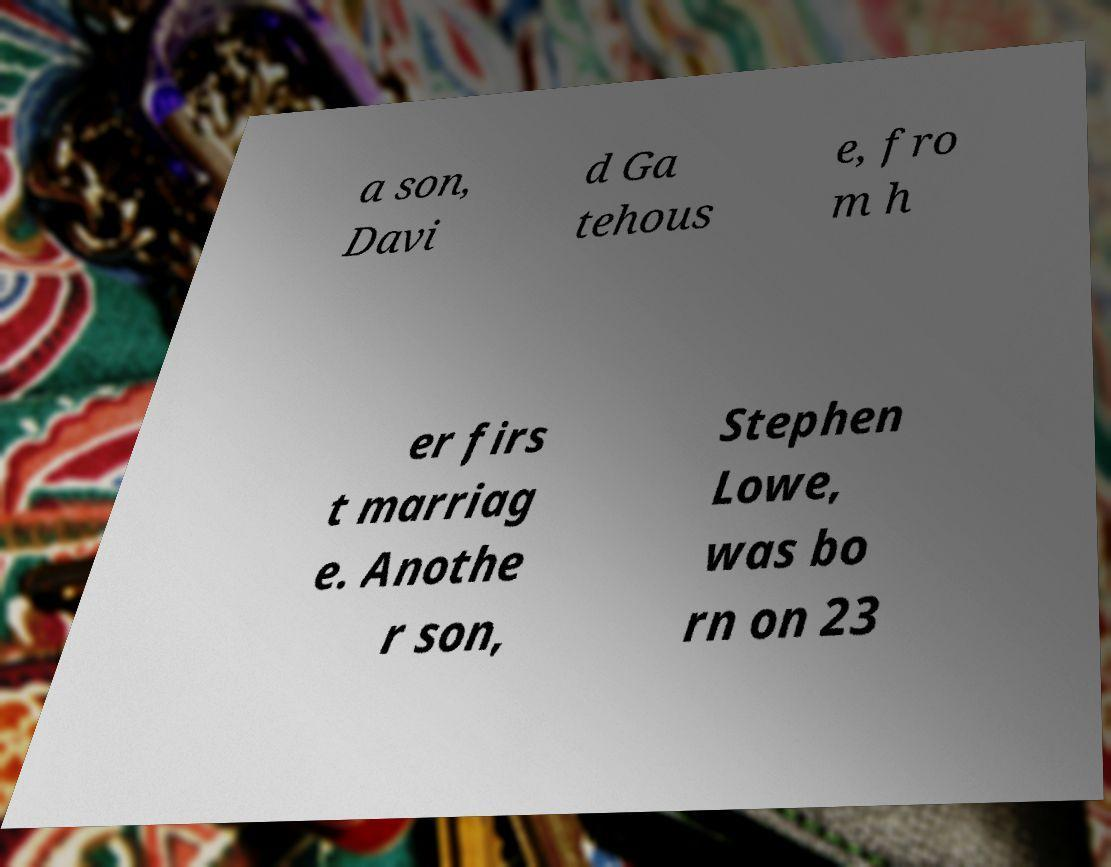Please identify and transcribe the text found in this image. a son, Davi d Ga tehous e, fro m h er firs t marriag e. Anothe r son, Stephen Lowe, was bo rn on 23 